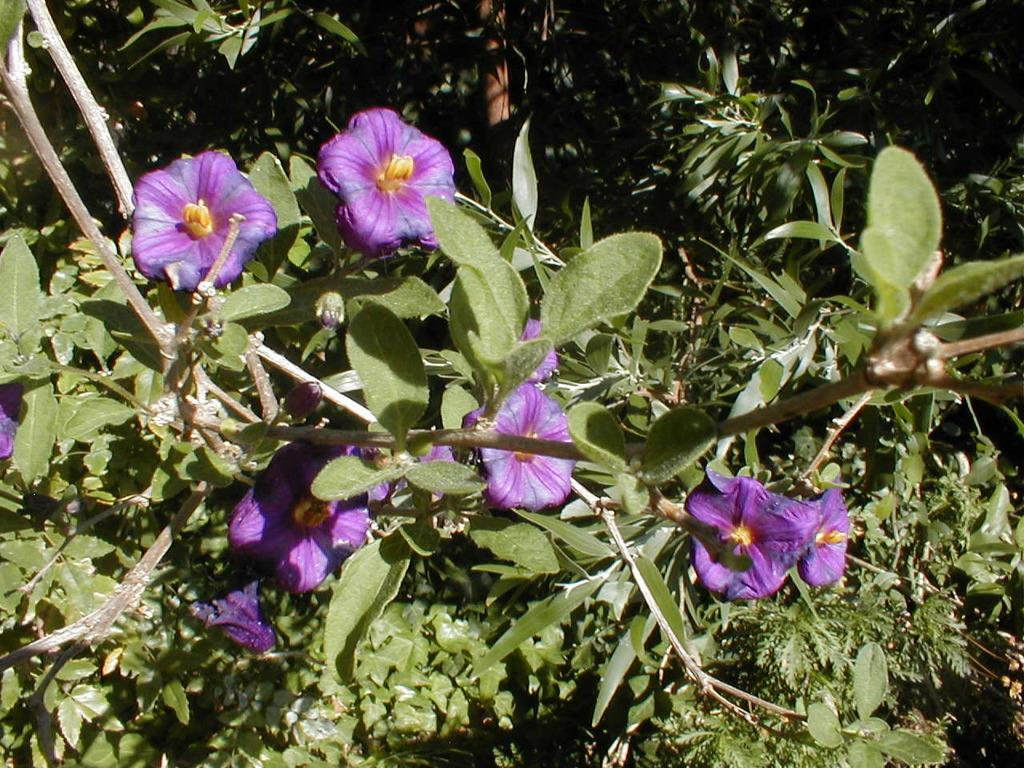What types of living organisms are in the image? There are many plants in the image. What specific features can be seen on the plants? There are flowers in the image. What color are the flowers? The flowers are in violet color. What type of shirt is being worn by the nail in the image? There is no shirt or nail present in the image; it features many plants and flowers. 